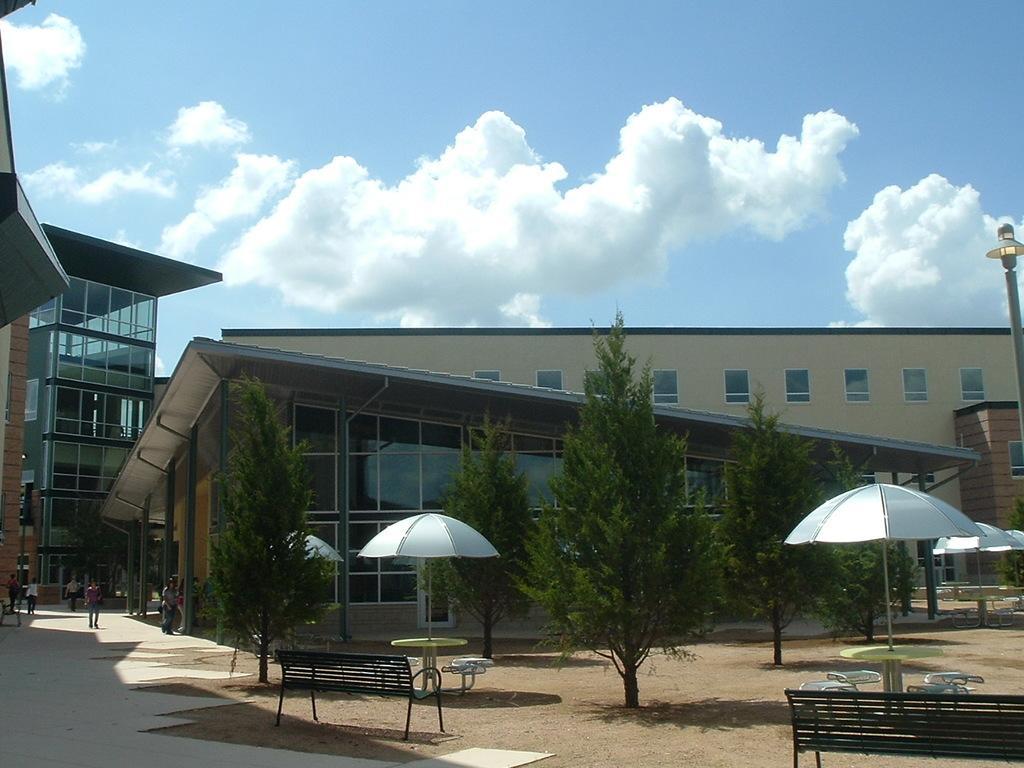In one or two sentences, can you explain what this image depicts? In this image I can see the floor, the ground, few benches, few chairs and few umbrellas which are white in color. I can see few trees, few persons standing on the ground and few buildings. I can see a pole and the sky in the background. 